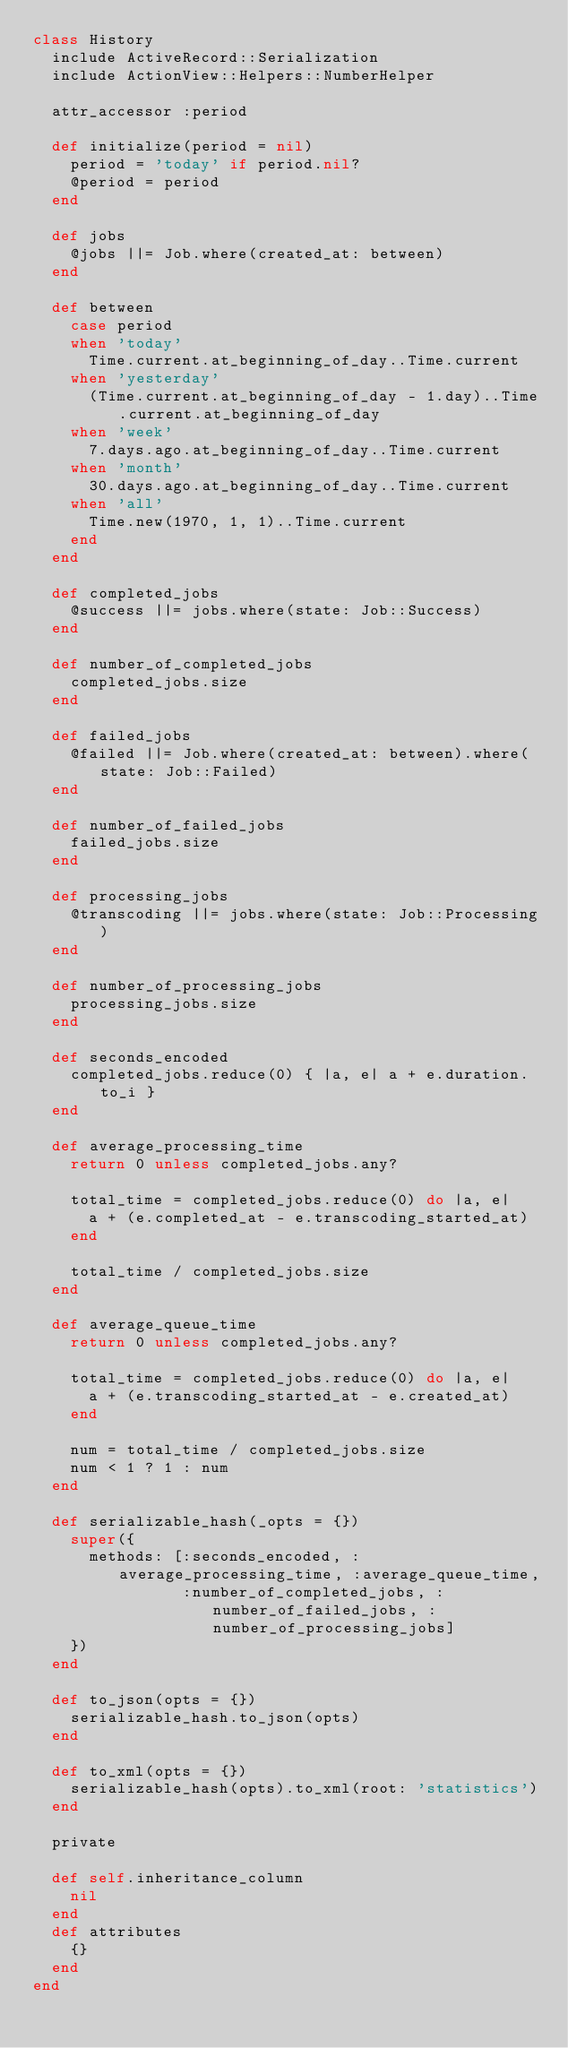<code> <loc_0><loc_0><loc_500><loc_500><_Ruby_>class History
  include ActiveRecord::Serialization
  include ActionView::Helpers::NumberHelper

  attr_accessor :period

  def initialize(period = nil)
    period = 'today' if period.nil?
    @period = period
  end

  def jobs
    @jobs ||= Job.where(created_at: between)
  end

  def between
    case period
    when 'today'
      Time.current.at_beginning_of_day..Time.current
    when 'yesterday'
      (Time.current.at_beginning_of_day - 1.day)..Time.current.at_beginning_of_day
    when 'week'
      7.days.ago.at_beginning_of_day..Time.current
    when 'month'
      30.days.ago.at_beginning_of_day..Time.current
    when 'all'
      Time.new(1970, 1, 1)..Time.current
    end
  end

  def completed_jobs
    @success ||= jobs.where(state: Job::Success)
  end

  def number_of_completed_jobs
    completed_jobs.size
  end

  def failed_jobs
    @failed ||= Job.where(created_at: between).where(state: Job::Failed)
  end

  def number_of_failed_jobs
    failed_jobs.size
  end

  def processing_jobs
    @transcoding ||= jobs.where(state: Job::Processing)
  end

  def number_of_processing_jobs
    processing_jobs.size
  end

  def seconds_encoded
    completed_jobs.reduce(0) { |a, e| a + e.duration.to_i }
  end

  def average_processing_time
    return 0 unless completed_jobs.any?

    total_time = completed_jobs.reduce(0) do |a, e|
      a + (e.completed_at - e.transcoding_started_at)
    end

    total_time / completed_jobs.size
  end

  def average_queue_time
    return 0 unless completed_jobs.any?

    total_time = completed_jobs.reduce(0) do |a, e|
      a + (e.transcoding_started_at - e.created_at)
    end

    num = total_time / completed_jobs.size
    num < 1 ? 1 : num
  end

  def serializable_hash(_opts = {})
    super({
      methods: [:seconds_encoded, :average_processing_time, :average_queue_time,
                :number_of_completed_jobs, :number_of_failed_jobs, :number_of_processing_jobs]
    })
  end

  def to_json(opts = {})
    serializable_hash.to_json(opts)
  end

  def to_xml(opts = {})
    serializable_hash(opts).to_xml(root: 'statistics')
  end

  private

  def self.inheritance_column
    nil
  end
  def attributes
    {}
  end
end
</code> 